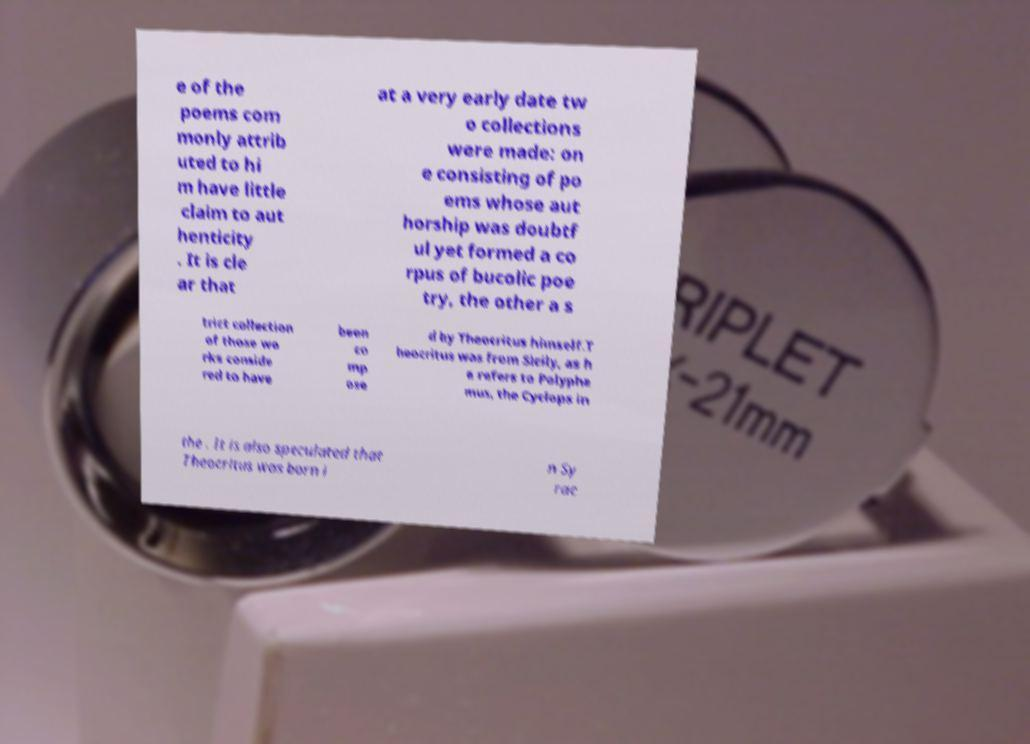For documentation purposes, I need the text within this image transcribed. Could you provide that? e of the poems com monly attrib uted to hi m have little claim to aut henticity . It is cle ar that at a very early date tw o collections were made: on e consisting of po ems whose aut horship was doubtf ul yet formed a co rpus of bucolic poe try, the other a s trict collection of those wo rks conside red to have been co mp ose d by Theocritus himself.T heocritus was from Sicily, as h e refers to Polyphe mus, the Cyclops in the . It is also speculated that Theocritus was born i n Sy rac 